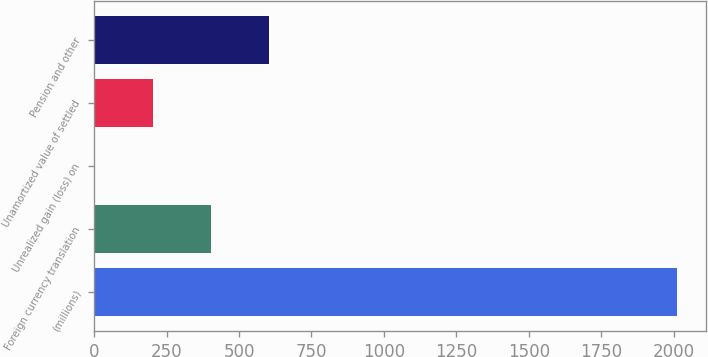Convert chart. <chart><loc_0><loc_0><loc_500><loc_500><bar_chart><fcel>(millions)<fcel>Foreign currency translation<fcel>Unrealized gain (loss) on<fcel>Unamortized value of settled<fcel>Pension and other<nl><fcel>2011<fcel>403.08<fcel>1.1<fcel>202.09<fcel>604.07<nl></chart> 